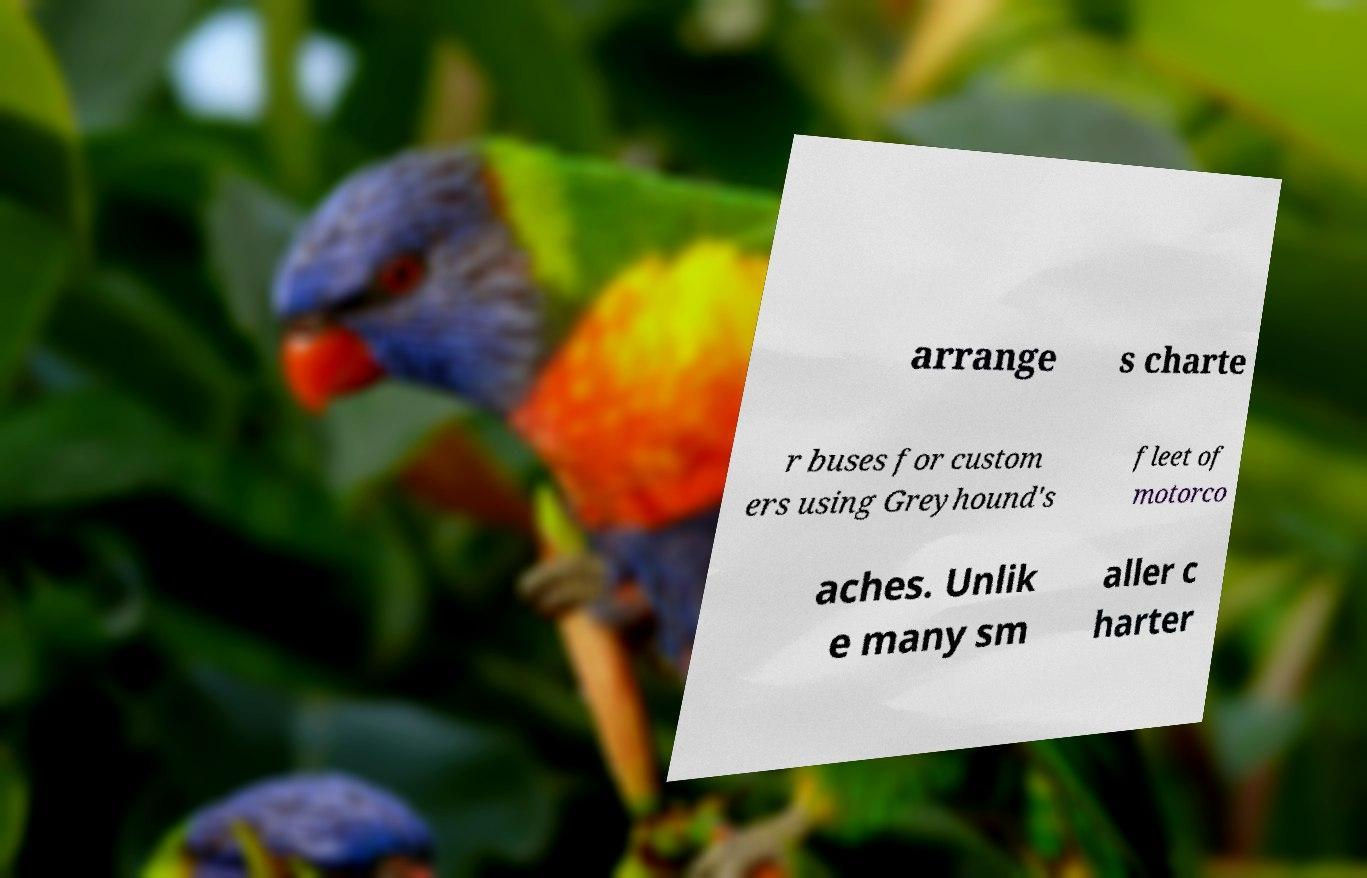Can you accurately transcribe the text from the provided image for me? arrange s charte r buses for custom ers using Greyhound's fleet of motorco aches. Unlik e many sm aller c harter 